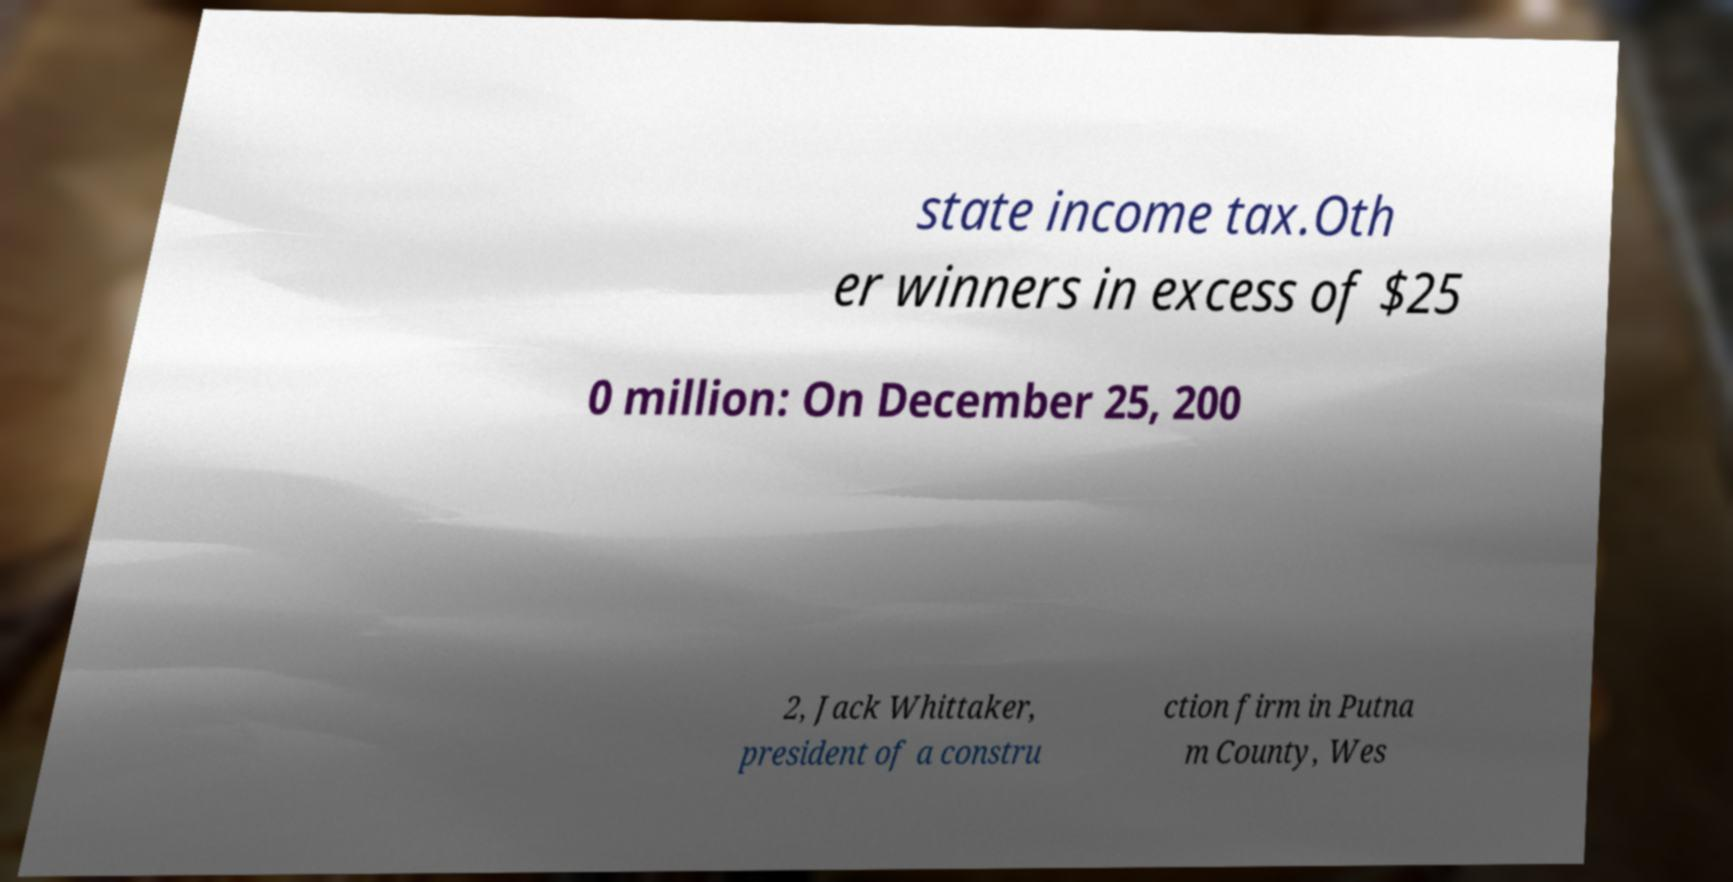For documentation purposes, I need the text within this image transcribed. Could you provide that? state income tax.Oth er winners in excess of $25 0 million: On December 25, 200 2, Jack Whittaker, president of a constru ction firm in Putna m County, Wes 